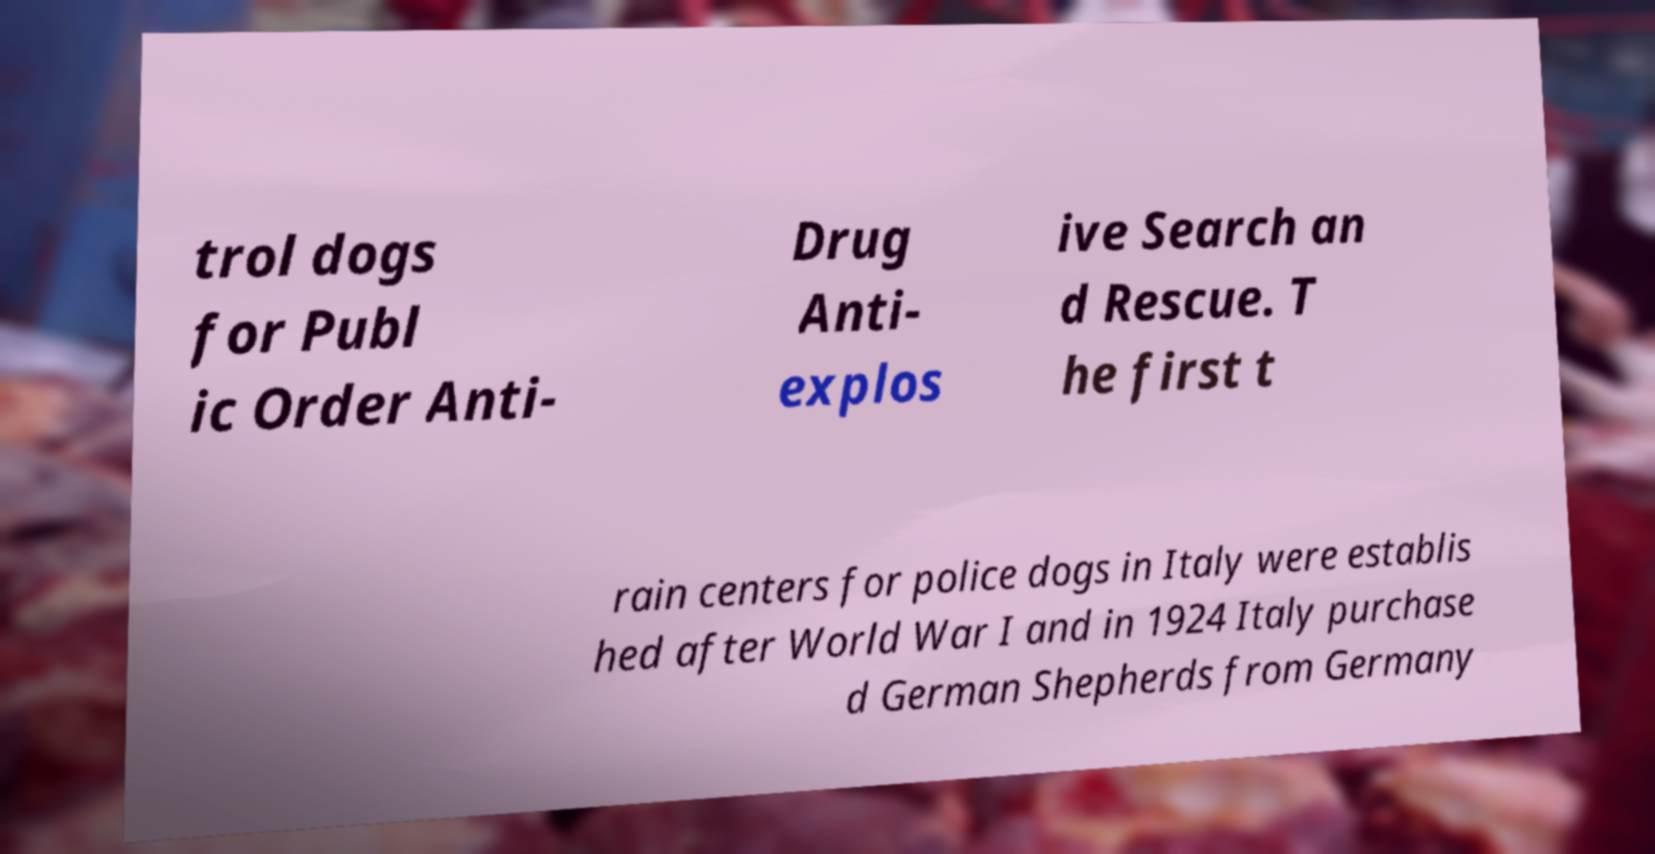Can you read and provide the text displayed in the image?This photo seems to have some interesting text. Can you extract and type it out for me? trol dogs for Publ ic Order Anti- Drug Anti- explos ive Search an d Rescue. T he first t rain centers for police dogs in Italy were establis hed after World War I and in 1924 Italy purchase d German Shepherds from Germany 